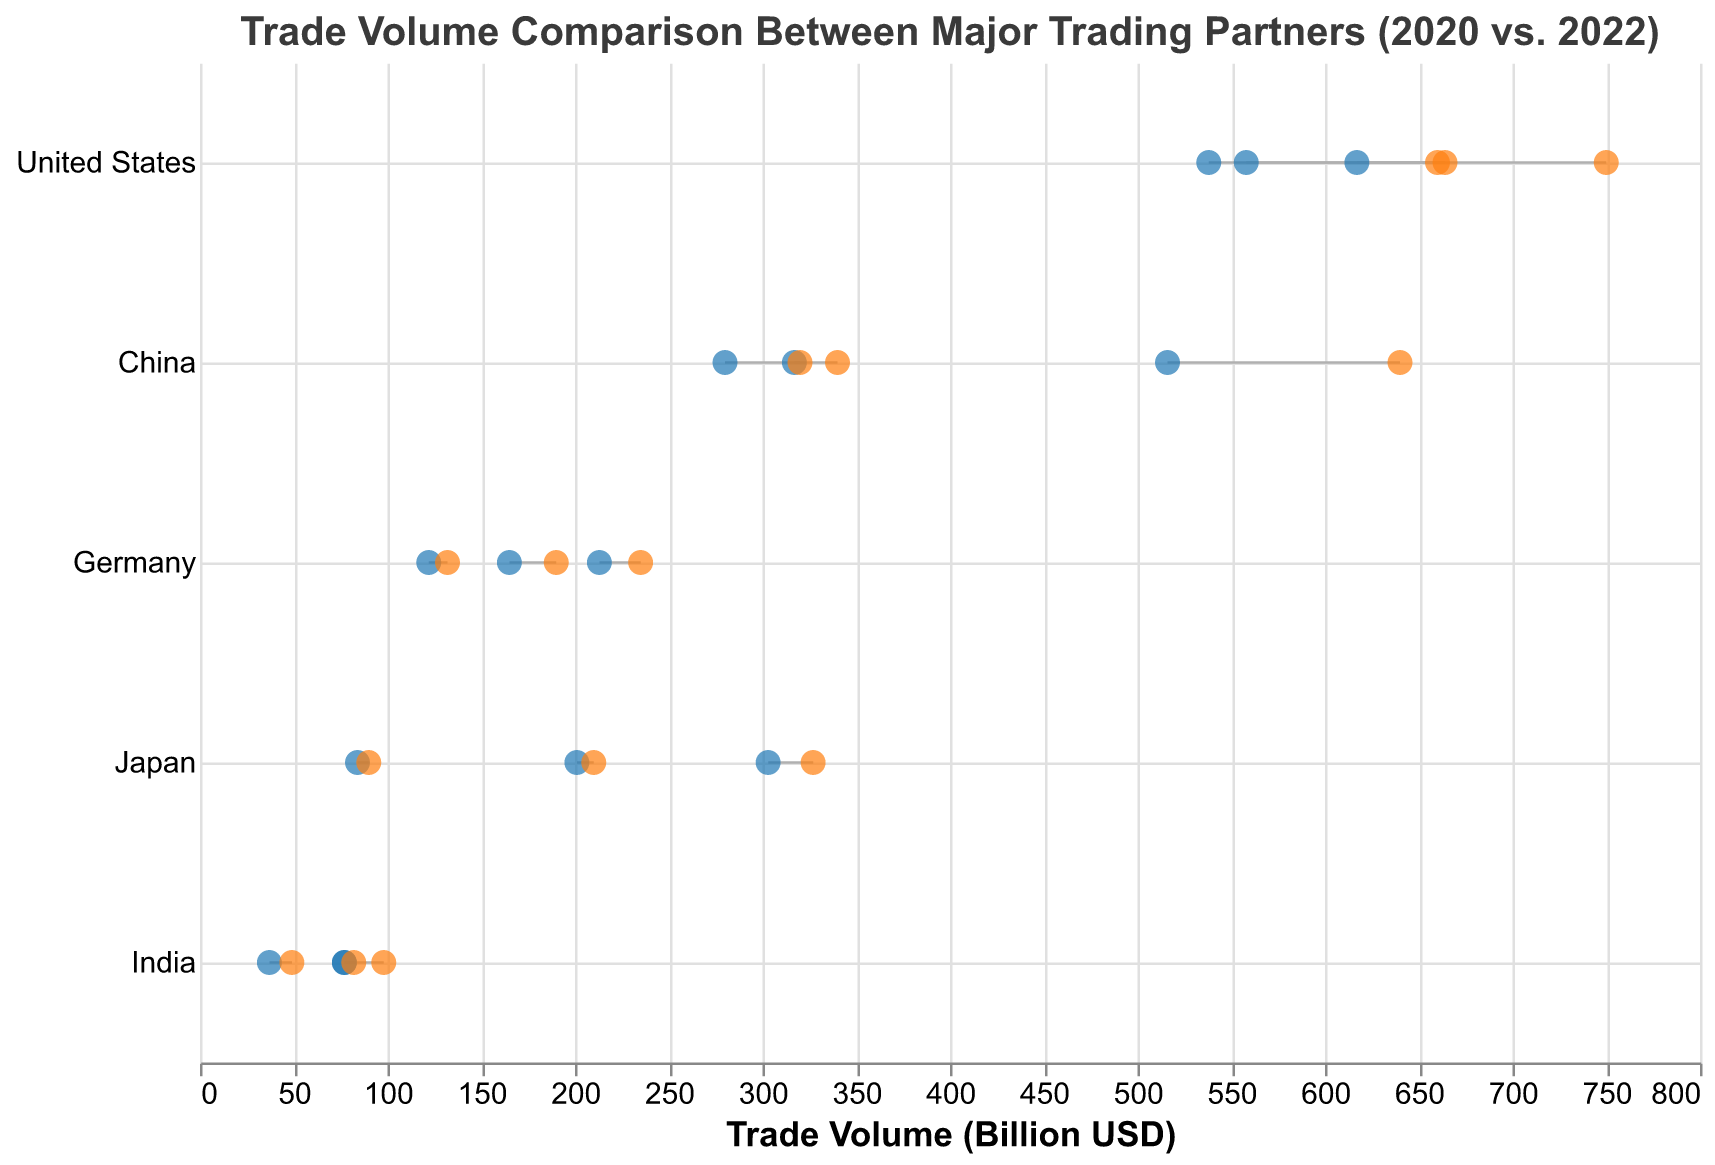What is the trade volume between the United States and China in 2022? According to the figure, the trade volume between the United States and China in 2022 is represented by the orange circle on the x-axis corresponding to the United States and Trade Partner China.
Answer: 660 billion USD Which country showed the largest increase in trade volume with their partners from 2020 to 2022? To determine the largest increase, we must look at the length of the line connecting the trade volume dots for each country. The United States with Canada showed the largest increase as it went from 617 billion USD in 2020 to 750 billion USD in 2022, an increase of 133 billion USD.
Answer: United States (with Canada) What is the total trade volume for the United States in 2020 across all listed trading partners? Adding the trade volumes from 2020 for the United States with China, Canada, and Mexico: 558 + 617 + 538 = 1713 billion USD.
Answer: 1713 billion USD Which pair of countries had the smallest trade volume increase between 2020 and 2022? The smallest increase can be observed by finding the shortest line between the trade volumes in 2020 and 2022. The shortest line corresponds to Japan and the United States, with an increase from 201 in 2020 to 210 in 2022, an increase of 9 billion USD.
Answer: Japan and United States Was the trade volume between India and China higher in 2020 or 2022? By looking at the trade volume circles for India and China, we see the circles for 2022 are on the right of those for 2020, indicating an increase. So, the trade volume was higher in 2022 at 98 billion USD compared to 77 billion USD in 2020.
Answer: 2022 What is the average trade volume between China and its listed trading partners in 2022? The listed trading partners for China are the United States, Japan, and South Korea. Summing their 2022 trade volumes: 640 + 340 + 320 = 1300 billion USD. Dividing by the number of trading partners, 1300 / 3 = 433.33 billion USD.
Answer: 433.33 billion USD Which trading partner had the largest difference in trade volume with India between 2020 and 2022? We need to look for the partner with the longest line connecting their trade volumes in India from 2020 and 2022. The largest difference is with China, where the trade volume increased from 77 billion USD in 2020 to 98 billion USD in 2022, a difference of 21 billion USD.
Answer: China Did Germany's trade volume with the Netherlands surpass 130 billion USD in 2022? According to the plot, Germany's trade volume with the Netherlands in 2022 is represented by the orange circle corresponding to Germany and Trade Partner Netherlands, which is exactly at 132 billion USD, thus surpassing 130 billion USD.
Answer: Yes What is the increase in trade volume between Japan and South Korea from 2020 to 2022? Japan's trade volume with South Korea increased from 84 billion USD in 2020 to 90 billion USD in 2022, which is an increase of 6 billion USD.
Answer: 6 billion USD Which trading partner for Germany showed the smallest increase in trade volume from 2020 to 2022? For Germany, the trading partners listed are the United States, China, and the Netherlands. Comparing the differences, the smallest increase is from the Netherlands, where the trade volume increased from 122 billion USD to 132 billion USD, a difference of 10 billion USD.
Answer: Netherlands 